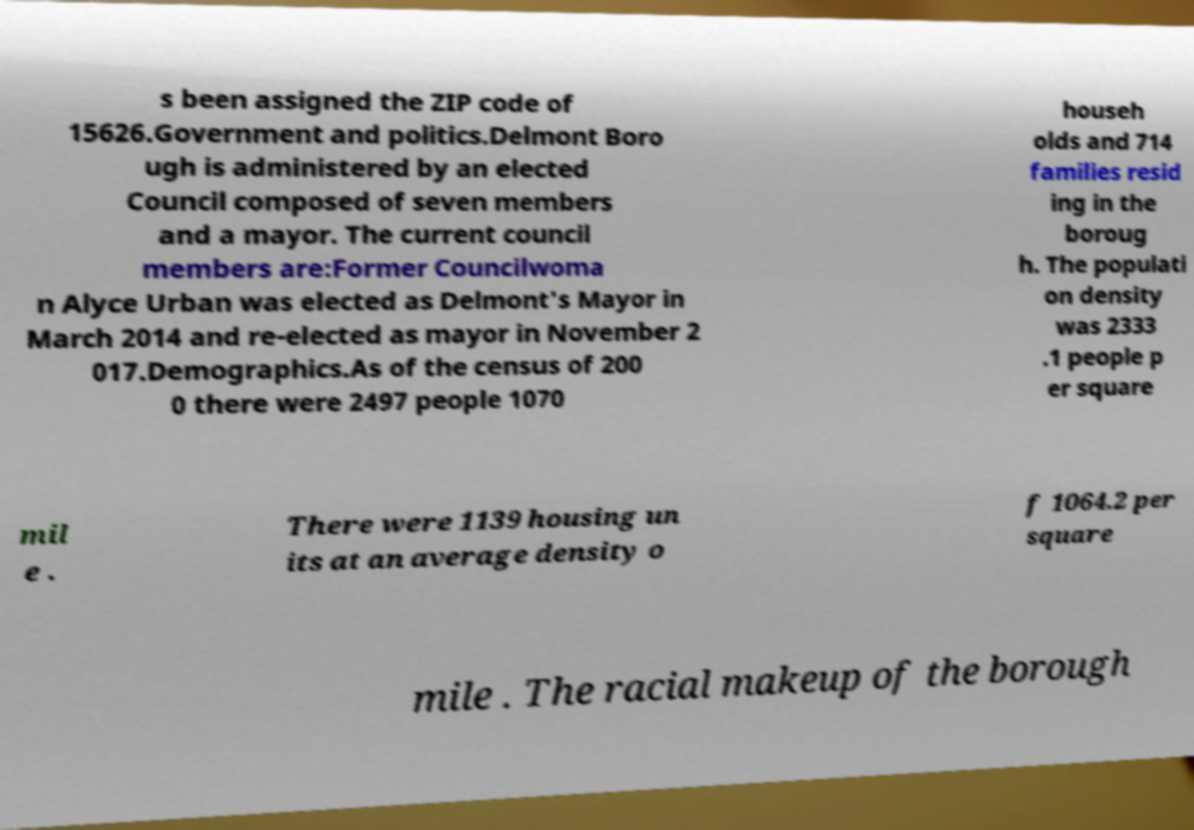Could you assist in decoding the text presented in this image and type it out clearly? s been assigned the ZIP code of 15626.Government and politics.Delmont Boro ugh is administered by an elected Council composed of seven members and a mayor. The current council members are:Former Councilwoma n Alyce Urban was elected as Delmont's Mayor in March 2014 and re-elected as mayor in November 2 017.Demographics.As of the census of 200 0 there were 2497 people 1070 househ olds and 714 families resid ing in the boroug h. The populati on density was 2333 .1 people p er square mil e . There were 1139 housing un its at an average density o f 1064.2 per square mile . The racial makeup of the borough 